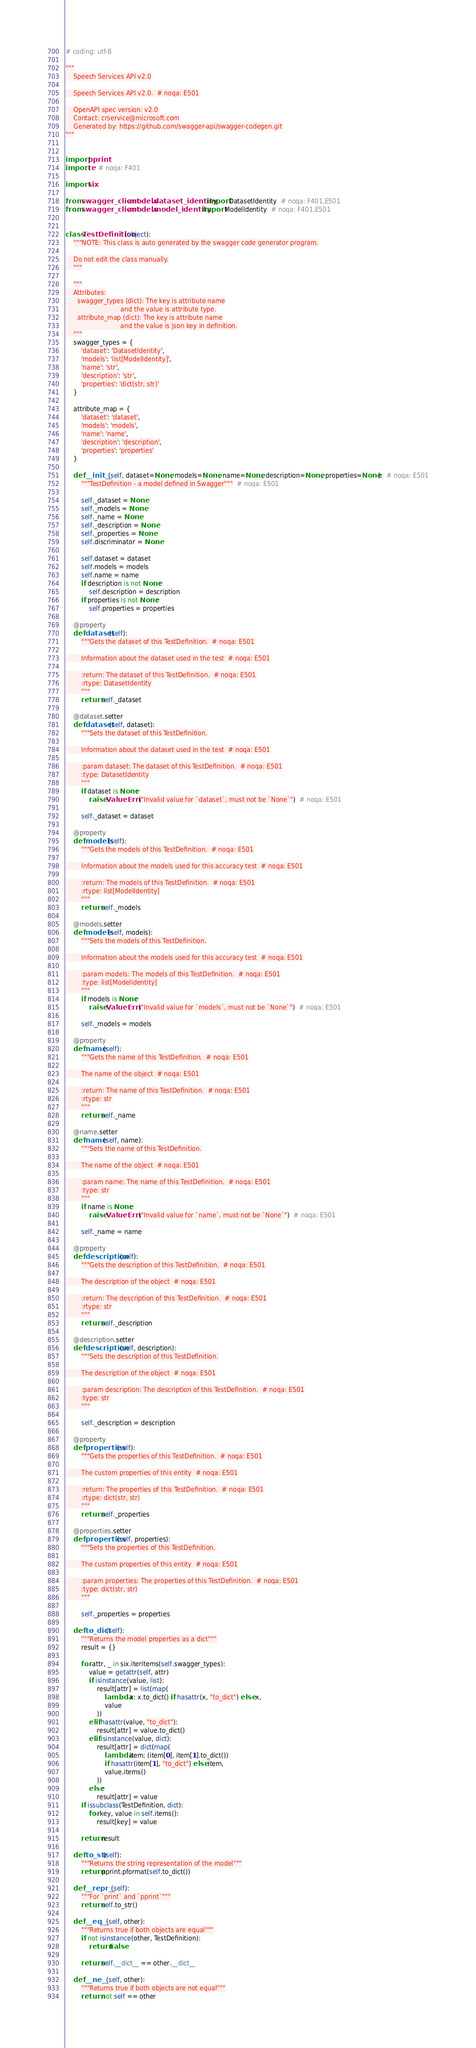Convert code to text. <code><loc_0><loc_0><loc_500><loc_500><_Python_># coding: utf-8

"""
    Speech Services API v2.0

    Speech Services API v2.0.  # noqa: E501

    OpenAPI spec version: v2.0
    Contact: crservice@microsoft.com
    Generated by: https://github.com/swagger-api/swagger-codegen.git
"""


import pprint
import re  # noqa: F401

import six

from swagger_client.models.dataset_identity import DatasetIdentity  # noqa: F401,E501
from swagger_client.models.model_identity import ModelIdentity  # noqa: F401,E501


class TestDefinition(object):
    """NOTE: This class is auto generated by the swagger code generator program.

    Do not edit the class manually.
    """

    """
    Attributes:
      swagger_types (dict): The key is attribute name
                            and the value is attribute type.
      attribute_map (dict): The key is attribute name
                            and the value is json key in definition.
    """
    swagger_types = {
        'dataset': 'DatasetIdentity',
        'models': 'list[ModelIdentity]',
        'name': 'str',
        'description': 'str',
        'properties': 'dict(str, str)'
    }

    attribute_map = {
        'dataset': 'dataset',
        'models': 'models',
        'name': 'name',
        'description': 'description',
        'properties': 'properties'
    }

    def __init__(self, dataset=None, models=None, name=None, description=None, properties=None):  # noqa: E501
        """TestDefinition - a model defined in Swagger"""  # noqa: E501

        self._dataset = None
        self._models = None
        self._name = None
        self._description = None
        self._properties = None
        self.discriminator = None

        self.dataset = dataset
        self.models = models
        self.name = name
        if description is not None:
            self.description = description
        if properties is not None:
            self.properties = properties

    @property
    def dataset(self):
        """Gets the dataset of this TestDefinition.  # noqa: E501

        Information about the dataset used in the test  # noqa: E501

        :return: The dataset of this TestDefinition.  # noqa: E501
        :rtype: DatasetIdentity
        """
        return self._dataset

    @dataset.setter
    def dataset(self, dataset):
        """Sets the dataset of this TestDefinition.

        Information about the dataset used in the test  # noqa: E501

        :param dataset: The dataset of this TestDefinition.  # noqa: E501
        :type: DatasetIdentity
        """
        if dataset is None:
            raise ValueError("Invalid value for `dataset`, must not be `None`")  # noqa: E501

        self._dataset = dataset

    @property
    def models(self):
        """Gets the models of this TestDefinition.  # noqa: E501

        Information about the models used for this accuracy test  # noqa: E501

        :return: The models of this TestDefinition.  # noqa: E501
        :rtype: list[ModelIdentity]
        """
        return self._models

    @models.setter
    def models(self, models):
        """Sets the models of this TestDefinition.

        Information about the models used for this accuracy test  # noqa: E501

        :param models: The models of this TestDefinition.  # noqa: E501
        :type: list[ModelIdentity]
        """
        if models is None:
            raise ValueError("Invalid value for `models`, must not be `None`")  # noqa: E501

        self._models = models

    @property
    def name(self):
        """Gets the name of this TestDefinition.  # noqa: E501

        The name of the object  # noqa: E501

        :return: The name of this TestDefinition.  # noqa: E501
        :rtype: str
        """
        return self._name

    @name.setter
    def name(self, name):
        """Sets the name of this TestDefinition.

        The name of the object  # noqa: E501

        :param name: The name of this TestDefinition.  # noqa: E501
        :type: str
        """
        if name is None:
            raise ValueError("Invalid value for `name`, must not be `None`")  # noqa: E501

        self._name = name

    @property
    def description(self):
        """Gets the description of this TestDefinition.  # noqa: E501

        The description of the object  # noqa: E501

        :return: The description of this TestDefinition.  # noqa: E501
        :rtype: str
        """
        return self._description

    @description.setter
    def description(self, description):
        """Sets the description of this TestDefinition.

        The description of the object  # noqa: E501

        :param description: The description of this TestDefinition.  # noqa: E501
        :type: str
        """

        self._description = description

    @property
    def properties(self):
        """Gets the properties of this TestDefinition.  # noqa: E501

        The custom properties of this entity  # noqa: E501

        :return: The properties of this TestDefinition.  # noqa: E501
        :rtype: dict(str, str)
        """
        return self._properties

    @properties.setter
    def properties(self, properties):
        """Sets the properties of this TestDefinition.

        The custom properties of this entity  # noqa: E501

        :param properties: The properties of this TestDefinition.  # noqa: E501
        :type: dict(str, str)
        """

        self._properties = properties

    def to_dict(self):
        """Returns the model properties as a dict"""
        result = {}

        for attr, _ in six.iteritems(self.swagger_types):
            value = getattr(self, attr)
            if isinstance(value, list):
                result[attr] = list(map(
                    lambda x: x.to_dict() if hasattr(x, "to_dict") else x,
                    value
                ))
            elif hasattr(value, "to_dict"):
                result[attr] = value.to_dict()
            elif isinstance(value, dict):
                result[attr] = dict(map(
                    lambda item: (item[0], item[1].to_dict())
                    if hasattr(item[1], "to_dict") else item,
                    value.items()
                ))
            else:
                result[attr] = value
        if issubclass(TestDefinition, dict):
            for key, value in self.items():
                result[key] = value

        return result

    def to_str(self):
        """Returns the string representation of the model"""
        return pprint.pformat(self.to_dict())

    def __repr__(self):
        """For `print` and `pprint`"""
        return self.to_str()

    def __eq__(self, other):
        """Returns true if both objects are equal"""
        if not isinstance(other, TestDefinition):
            return False

        return self.__dict__ == other.__dict__

    def __ne__(self, other):
        """Returns true if both objects are not equal"""
        return not self == other
</code> 